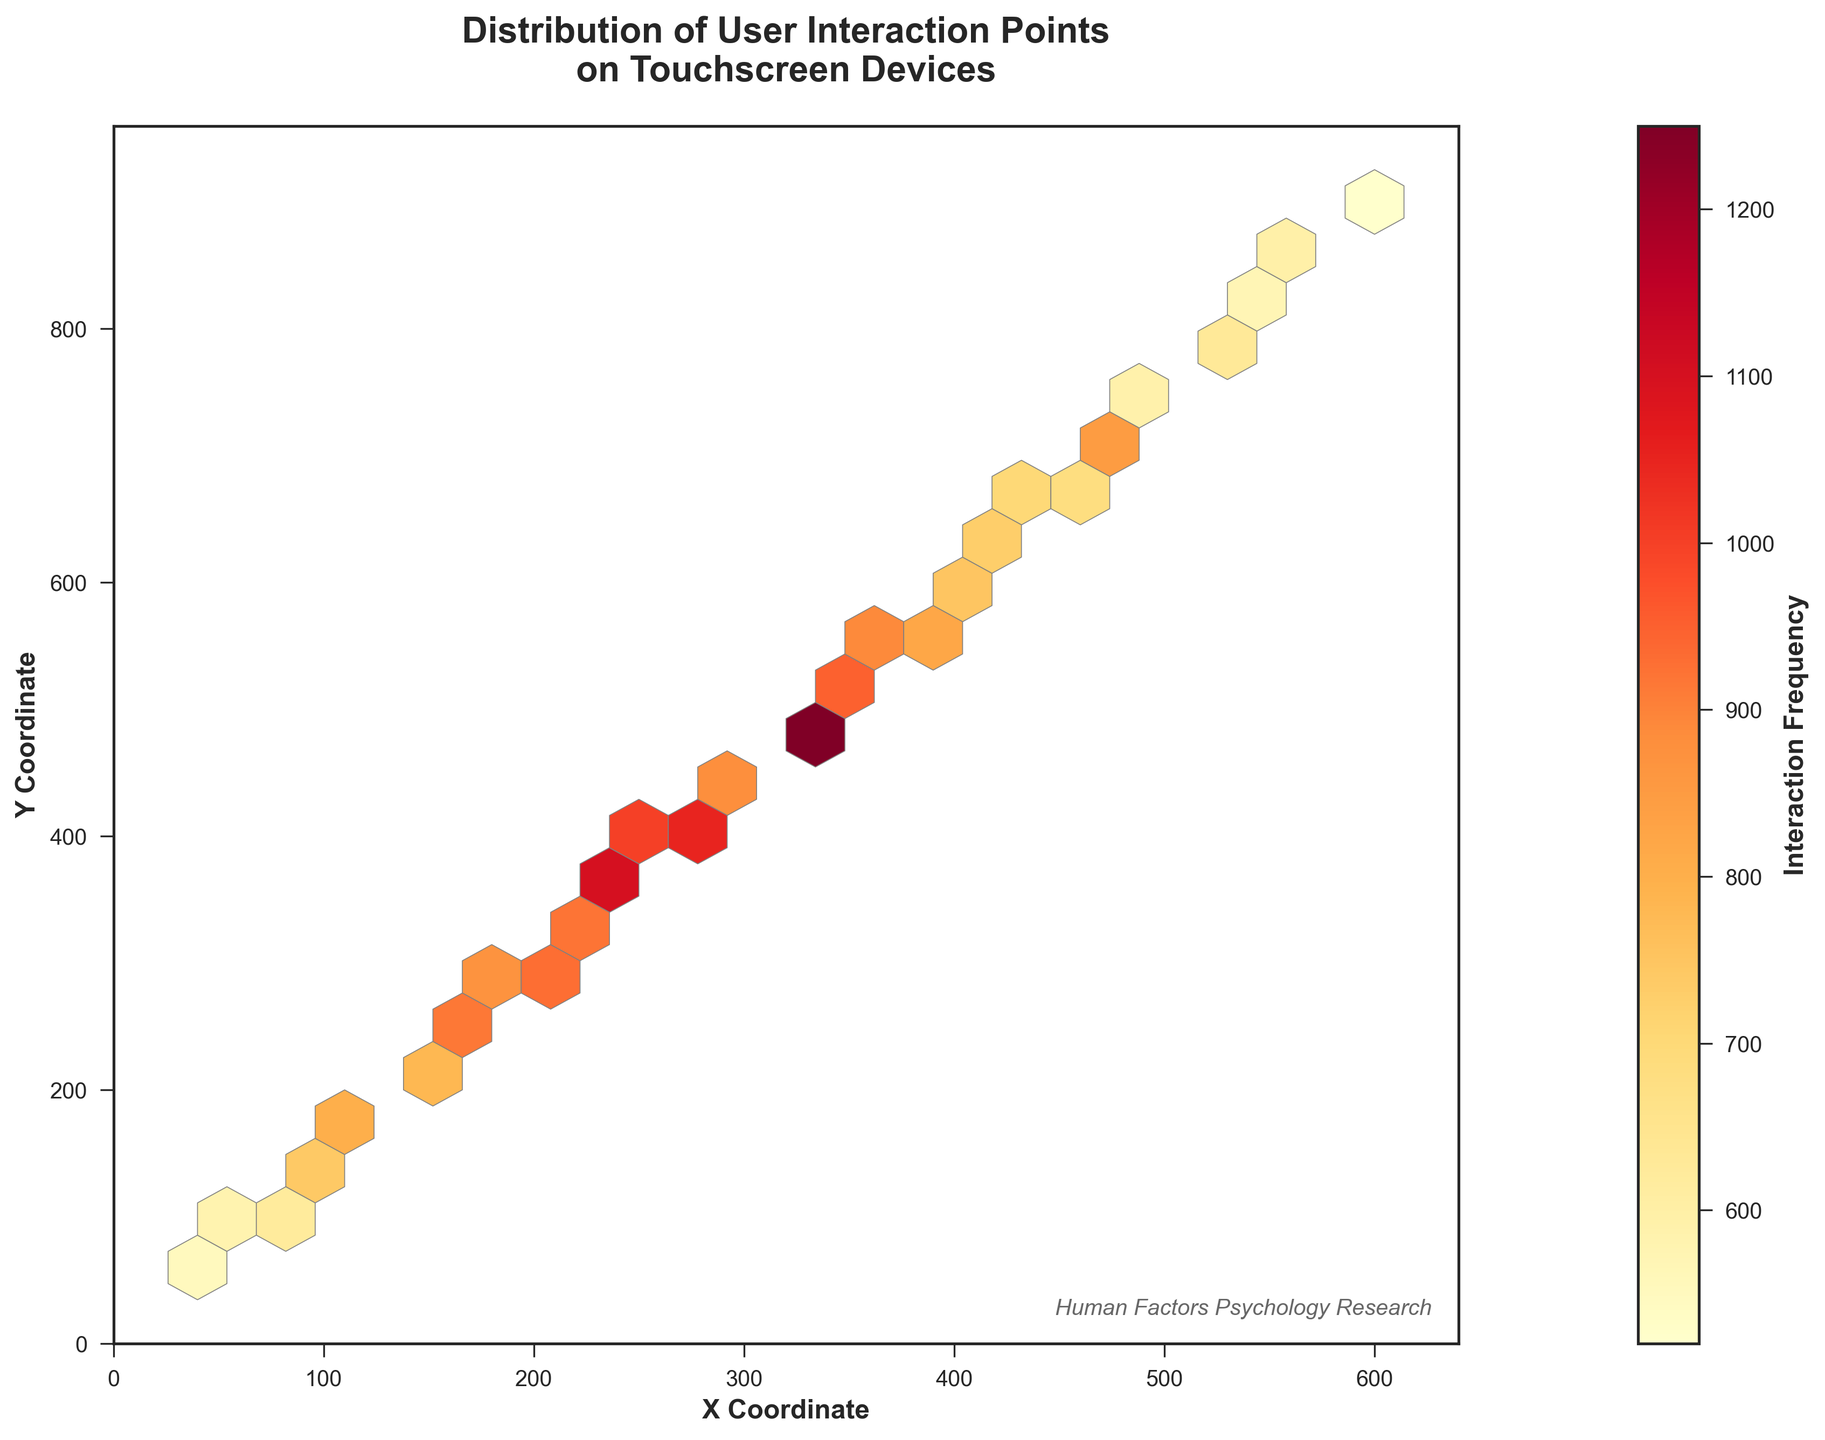What's the title of the figure? The title of a figure is typically at the top and provides an overview of what the plot represents. In this case, it's placed prominently above the hexbin plot.
Answer: Distribution of User Interaction Points on Touchscreen Devices What are the labels of the axes? Axis labels describe what each axis represents. Here, they are positioned alongside the respective axes. The X-axis label is at the bottom, and the Y-axis label is on the left side of the plot.
Answer: X Coordinate and Y Coordinate Which color represents the highest interaction frequency in the plot? In hexbin plots with a heatmap, darker or more intense colors typically represent higher values. The color scale ranges from light (lower frequency) to dark (higher frequency).
Answer: Red What is the x-coordinate range displayed on the plot? When looking at a figure's X-axis, the minimum and maximum values tell us the range. This is indicated at both ends of the axis.
Answer: 0 to 640 Which area has the highest user interaction frequency? To determine the area with the highest frequency, look for the hexagon with the darkest color, which indicates the highest tally of recorded interactions.
Answer: Around (320, 480) Compare the interaction frequency around the coordinates (160, 240) and (560, 840). Which area has higher interactions? Comparisons require looking at the colors of the bins near the coordinates. Darker hexagons signify higher interaction frequencies.
Answer: (160, 240) What's the average interaction frequency of the data points provided? To find the average, sum all the interaction frequencies and then divide by the number of data points. The sum is 23590, and there are 30 data points, so the average is 23590 / 30 = 786.33.
Answer: 786.33 Which hexagon in the plot has the least interaction frequency and where is it located? The lightest colored or barely visible hexagons represent the least frequency. We need to identify the specific lightest hexagon and its location.
Answer: Around (600, 900) Is there a hexagon at coordinates (80, 120) and what's its frequency? Check if there is a hexagon at these coordinates and note the color intensity to infer its frequency.
Answer: Yes, 620 By looking at the heatmap, which area would you recommend designers to focus on for optimizing user interactions? Areas with the highest interactions are critical for optimization. These are indicated by the strongest color intensity, suggesting where users frequently tap.
Answer: Around (320, 480) 